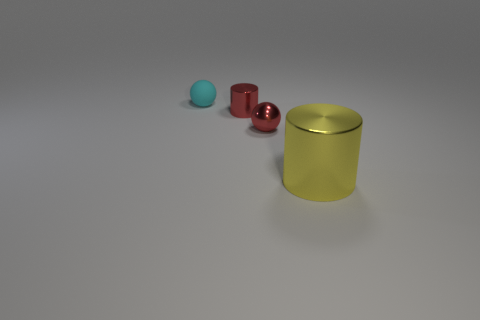There is a tiny red metal thing in front of the red cylinder; does it have the same shape as the tiny rubber object?
Your answer should be very brief. Yes. How many objects are tiny balls or tiny red things?
Make the answer very short. 3. Do the sphere behind the red metallic sphere and the large thing have the same material?
Provide a succinct answer. No. The shiny ball has what size?
Make the answer very short. Small. What shape is the small object that is the same color as the metallic sphere?
Your answer should be compact. Cylinder. How many cylinders are either yellow objects or small rubber objects?
Ensure brevity in your answer.  1. Are there an equal number of cyan spheres on the right side of the tiny cyan matte sphere and small shiny objects that are to the left of the shiny sphere?
Offer a terse response. No. What size is the red object that is the same shape as the cyan matte thing?
Ensure brevity in your answer.  Small. What size is the object that is both to the right of the cyan rubber object and behind the small red sphere?
Give a very brief answer. Small. There is a small cyan matte sphere; are there any small cyan matte spheres to the left of it?
Keep it short and to the point. No. 